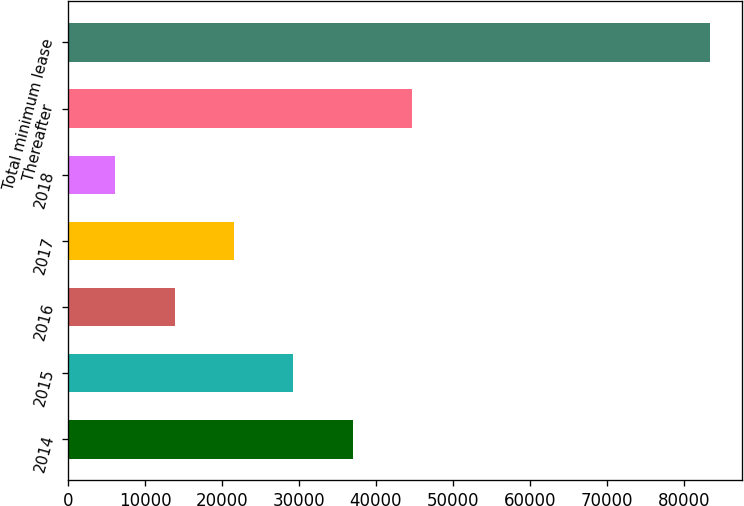<chart> <loc_0><loc_0><loc_500><loc_500><bar_chart><fcel>2014<fcel>2015<fcel>2016<fcel>2017<fcel>2018<fcel>Thereafter<fcel>Total minimum lease<nl><fcel>37013<fcel>29286<fcel>13832<fcel>21559<fcel>6105<fcel>44740<fcel>83375<nl></chart> 